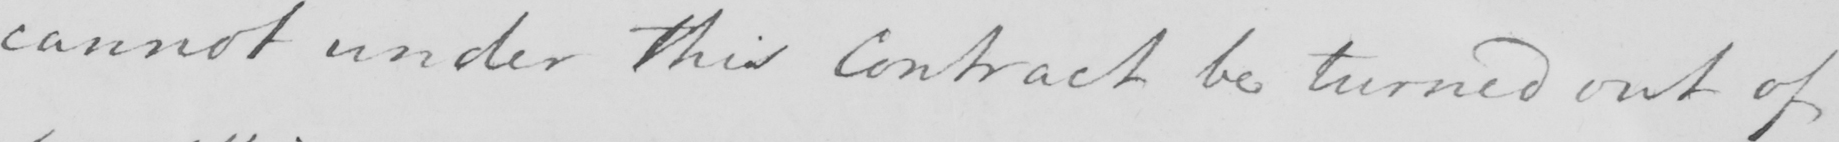Transcribe the text shown in this historical manuscript line. cannot under this Contract be turned out of 